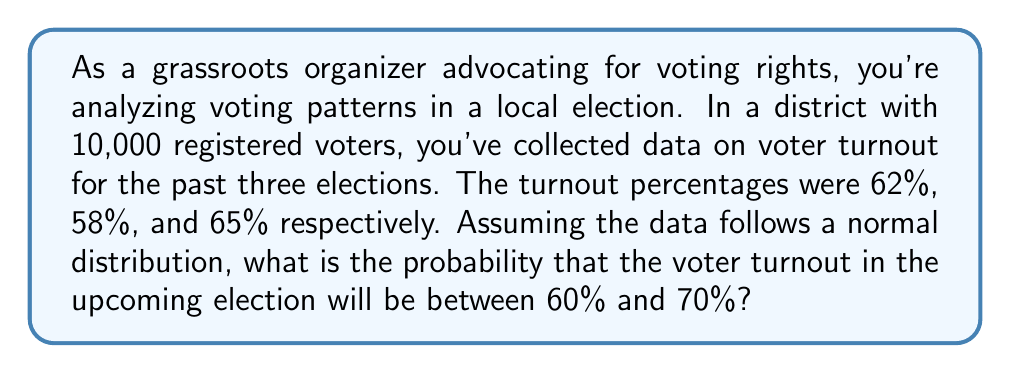What is the answer to this math problem? To solve this problem, we'll use the properties of the normal distribution and the z-score formula. Let's break it down step-by-step:

1. Calculate the mean ($\mu$) of the given turnout percentages:
   $$\mu = \frac{62\% + 58\% + 65\%}{3} = 61.67\%$$

2. Calculate the standard deviation ($\sigma$) of the turnout percentages:
   $$\sigma = \sqrt{\frac{\sum(x_i - \mu)^2}{n-1}}$$
   $$= \sqrt{\frac{(62 - 61.67)^2 + (58 - 61.67)^2 + (65 - 61.67)^2}{2}}$$
   $$= \sqrt{\frac{0.11 + 13.44 + 11.11}{2}} = \sqrt{12.33} \approx 3.51\%$$

3. Calculate the z-scores for 60% and 70%:
   $$z_1 = \frac{60 - 61.67}{3.51} \approx -0.47$$
   $$z_2 = \frac{70 - 61.67}{3.51} \approx 2.37$$

4. Find the area under the standard normal curve between these z-scores:
   $$P(-0.47 < Z < 2.37) = P(Z < 2.37) - P(Z < -0.47)$$

5. Using a standard normal table or calculator:
   $$P(Z < 2.37) \approx 0.9911$$
   $$P(Z < -0.47) \approx 0.3192$$

6. Calculate the final probability:
   $$P(-0.47 < Z < 2.37) = 0.9911 - 0.3192 = 0.6719$$

Therefore, the probability that the voter turnout in the upcoming election will be between 60% and 70% is approximately 0.6719 or 67.19%.
Answer: 0.6719 or 67.19% 